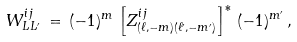Convert formula to latex. <formula><loc_0><loc_0><loc_500><loc_500>W ^ { i j } _ { L L ^ { \prime } } \, = \, ( - 1 ) ^ { m } \, \left [ Z ^ { i j } _ { ( \ell , - m ) ( \ell ^ { \prime } , - m ^ { \prime } ) } \right ] ^ { * } \, ( - 1 ) ^ { m ^ { \prime } } \, ,</formula> 